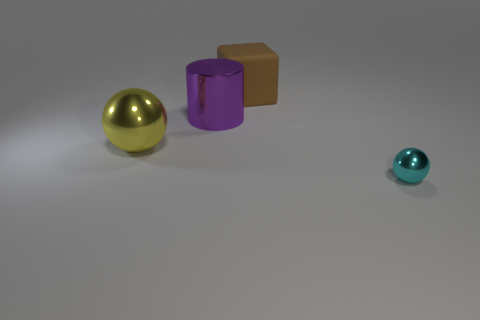Add 4 yellow rubber objects. How many objects exist? 8 Subtract all cylinders. How many objects are left? 3 Add 1 yellow cylinders. How many yellow cylinders exist? 1 Subtract 0 brown spheres. How many objects are left? 4 Subtract all spheres. Subtract all purple things. How many objects are left? 1 Add 3 small balls. How many small balls are left? 4 